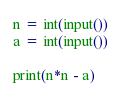<code> <loc_0><loc_0><loc_500><loc_500><_Python_>n = int(input())
a = int(input())

print(n*n - a)
</code> 